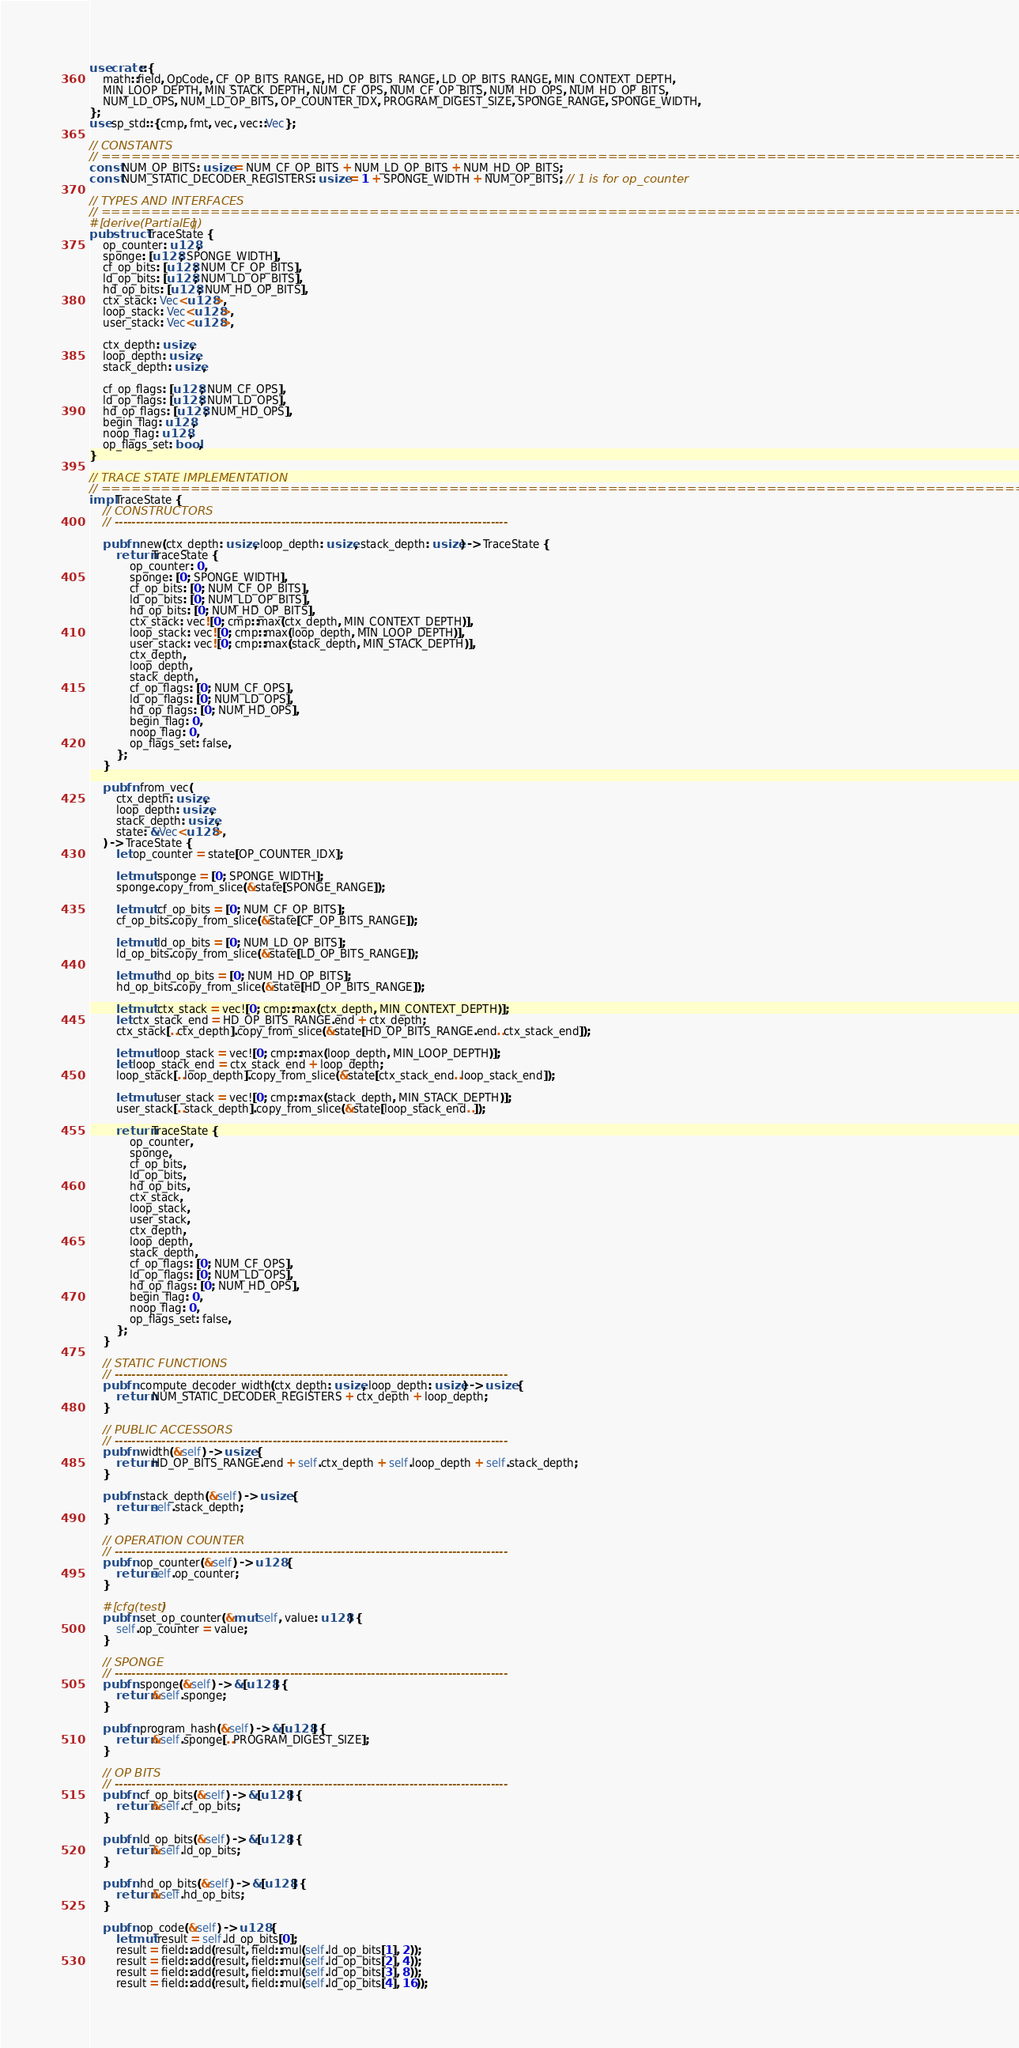Convert code to text. <code><loc_0><loc_0><loc_500><loc_500><_Rust_>use crate::{
    math::field, OpCode, CF_OP_BITS_RANGE, HD_OP_BITS_RANGE, LD_OP_BITS_RANGE, MIN_CONTEXT_DEPTH,
    MIN_LOOP_DEPTH, MIN_STACK_DEPTH, NUM_CF_OPS, NUM_CF_OP_BITS, NUM_HD_OPS, NUM_HD_OP_BITS,
    NUM_LD_OPS, NUM_LD_OP_BITS, OP_COUNTER_IDX, PROGRAM_DIGEST_SIZE, SPONGE_RANGE, SPONGE_WIDTH,
};
use sp_std::{cmp, fmt, vec, vec::Vec};

// CONSTANTS
// ================================================================================================
const NUM_OP_BITS: usize = NUM_CF_OP_BITS + NUM_LD_OP_BITS + NUM_HD_OP_BITS;
const NUM_STATIC_DECODER_REGISTERS: usize = 1 + SPONGE_WIDTH + NUM_OP_BITS; // 1 is for op_counter

// TYPES AND INTERFACES
// ================================================================================================
#[derive(PartialEq)]
pub struct TraceState {
    op_counter: u128,
    sponge: [u128; SPONGE_WIDTH],
    cf_op_bits: [u128; NUM_CF_OP_BITS],
    ld_op_bits: [u128; NUM_LD_OP_BITS],
    hd_op_bits: [u128; NUM_HD_OP_BITS],
    ctx_stack: Vec<u128>,
    loop_stack: Vec<u128>,
    user_stack: Vec<u128>,

    ctx_depth: usize,
    loop_depth: usize,
    stack_depth: usize,

    cf_op_flags: [u128; NUM_CF_OPS],
    ld_op_flags: [u128; NUM_LD_OPS],
    hd_op_flags: [u128; NUM_HD_OPS],
    begin_flag: u128,
    noop_flag: u128,
    op_flags_set: bool,
}

// TRACE STATE IMPLEMENTATION
// ================================================================================================
impl TraceState {
    // CONSTRUCTORS
    // --------------------------------------------------------------------------------------------

    pub fn new(ctx_depth: usize, loop_depth: usize, stack_depth: usize) -> TraceState {
        return TraceState {
            op_counter: 0,
            sponge: [0; SPONGE_WIDTH],
            cf_op_bits: [0; NUM_CF_OP_BITS],
            ld_op_bits: [0; NUM_LD_OP_BITS],
            hd_op_bits: [0; NUM_HD_OP_BITS],
            ctx_stack: vec![0; cmp::max(ctx_depth, MIN_CONTEXT_DEPTH)],
            loop_stack: vec![0; cmp::max(loop_depth, MIN_LOOP_DEPTH)],
            user_stack: vec![0; cmp::max(stack_depth, MIN_STACK_DEPTH)],
            ctx_depth,
            loop_depth,
            stack_depth,
            cf_op_flags: [0; NUM_CF_OPS],
            ld_op_flags: [0; NUM_LD_OPS],
            hd_op_flags: [0; NUM_HD_OPS],
            begin_flag: 0,
            noop_flag: 0,
            op_flags_set: false,
        };
    }

    pub fn from_vec(
        ctx_depth: usize,
        loop_depth: usize,
        stack_depth: usize,
        state: &Vec<u128>,
    ) -> TraceState {
        let op_counter = state[OP_COUNTER_IDX];

        let mut sponge = [0; SPONGE_WIDTH];
        sponge.copy_from_slice(&state[SPONGE_RANGE]);

        let mut cf_op_bits = [0; NUM_CF_OP_BITS];
        cf_op_bits.copy_from_slice(&state[CF_OP_BITS_RANGE]);

        let mut ld_op_bits = [0; NUM_LD_OP_BITS];
        ld_op_bits.copy_from_slice(&state[LD_OP_BITS_RANGE]);

        let mut hd_op_bits = [0; NUM_HD_OP_BITS];
        hd_op_bits.copy_from_slice(&state[HD_OP_BITS_RANGE]);

        let mut ctx_stack = vec![0; cmp::max(ctx_depth, MIN_CONTEXT_DEPTH)];
        let ctx_stack_end = HD_OP_BITS_RANGE.end + ctx_depth;
        ctx_stack[..ctx_depth].copy_from_slice(&state[HD_OP_BITS_RANGE.end..ctx_stack_end]);

        let mut loop_stack = vec![0; cmp::max(loop_depth, MIN_LOOP_DEPTH)];
        let loop_stack_end = ctx_stack_end + loop_depth;
        loop_stack[..loop_depth].copy_from_slice(&state[ctx_stack_end..loop_stack_end]);

        let mut user_stack = vec![0; cmp::max(stack_depth, MIN_STACK_DEPTH)];
        user_stack[..stack_depth].copy_from_slice(&state[loop_stack_end..]);

        return TraceState {
            op_counter,
            sponge,
            cf_op_bits,
            ld_op_bits,
            hd_op_bits,
            ctx_stack,
            loop_stack,
            user_stack,
            ctx_depth,
            loop_depth,
            stack_depth,
            cf_op_flags: [0; NUM_CF_OPS],
            ld_op_flags: [0; NUM_LD_OPS],
            hd_op_flags: [0; NUM_HD_OPS],
            begin_flag: 0,
            noop_flag: 0,
            op_flags_set: false,
        };
    }

    // STATIC FUNCTIONS
    // --------------------------------------------------------------------------------------------
    pub fn compute_decoder_width(ctx_depth: usize, loop_depth: usize) -> usize {
        return NUM_STATIC_DECODER_REGISTERS + ctx_depth + loop_depth;
    }

    // PUBLIC ACCESSORS
    // --------------------------------------------------------------------------------------------
    pub fn width(&self) -> usize {
        return HD_OP_BITS_RANGE.end + self.ctx_depth + self.loop_depth + self.stack_depth;
    }

    pub fn stack_depth(&self) -> usize {
        return self.stack_depth;
    }

    // OPERATION COUNTER
    // --------------------------------------------------------------------------------------------
    pub fn op_counter(&self) -> u128 {
        return self.op_counter;
    }

    #[cfg(test)]
    pub fn set_op_counter(&mut self, value: u128) {
        self.op_counter = value;
    }

    // SPONGE
    // --------------------------------------------------------------------------------------------
    pub fn sponge(&self) -> &[u128] {
        return &self.sponge;
    }

    pub fn program_hash(&self) -> &[u128] {
        return &self.sponge[..PROGRAM_DIGEST_SIZE];
    }

    // OP BITS
    // --------------------------------------------------------------------------------------------
    pub fn cf_op_bits(&self) -> &[u128] {
        return &self.cf_op_bits;
    }

    pub fn ld_op_bits(&self) -> &[u128] {
        return &self.ld_op_bits;
    }

    pub fn hd_op_bits(&self) -> &[u128] {
        return &self.hd_op_bits;
    }

    pub fn op_code(&self) -> u128 {
        let mut result = self.ld_op_bits[0];
        result = field::add(result, field::mul(self.ld_op_bits[1], 2));
        result = field::add(result, field::mul(self.ld_op_bits[2], 4));
        result = field::add(result, field::mul(self.ld_op_bits[3], 8));
        result = field::add(result, field::mul(self.ld_op_bits[4], 16));</code> 